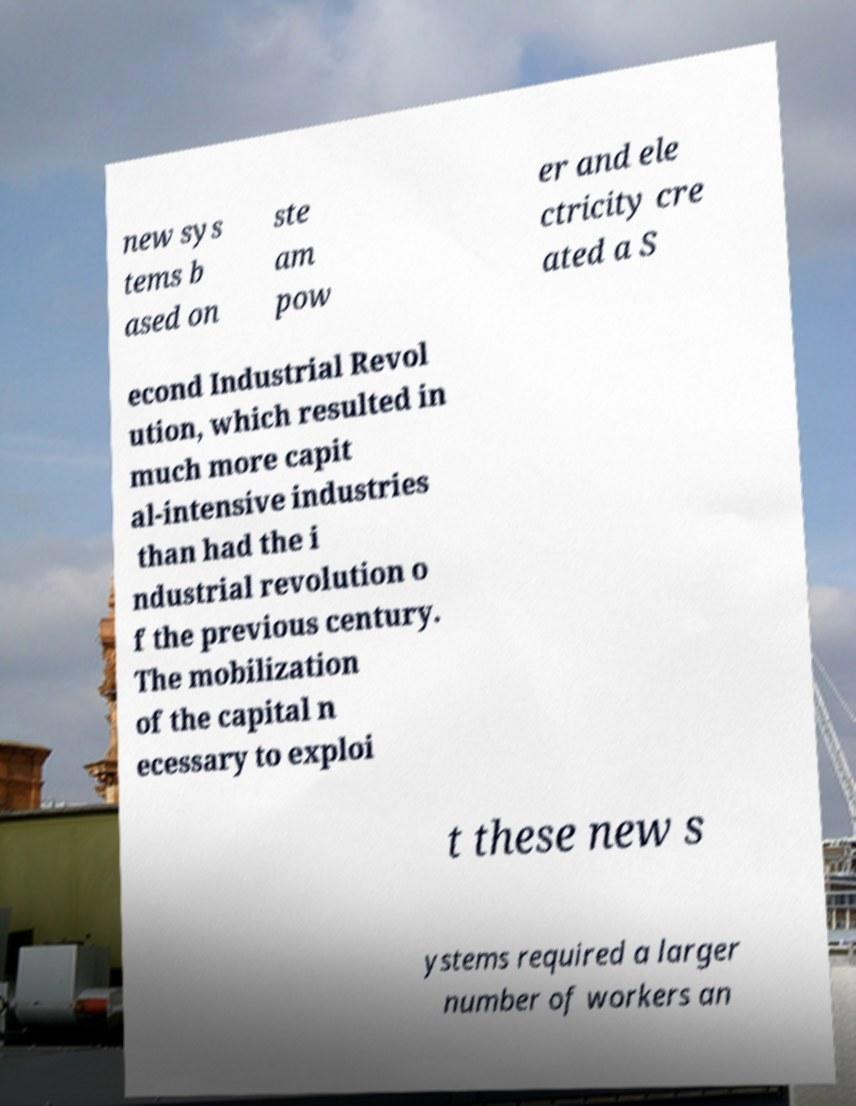I need the written content from this picture converted into text. Can you do that? new sys tems b ased on ste am pow er and ele ctricity cre ated a S econd Industrial Revol ution, which resulted in much more capit al-intensive industries than had the i ndustrial revolution o f the previous century. The mobilization of the capital n ecessary to exploi t these new s ystems required a larger number of workers an 